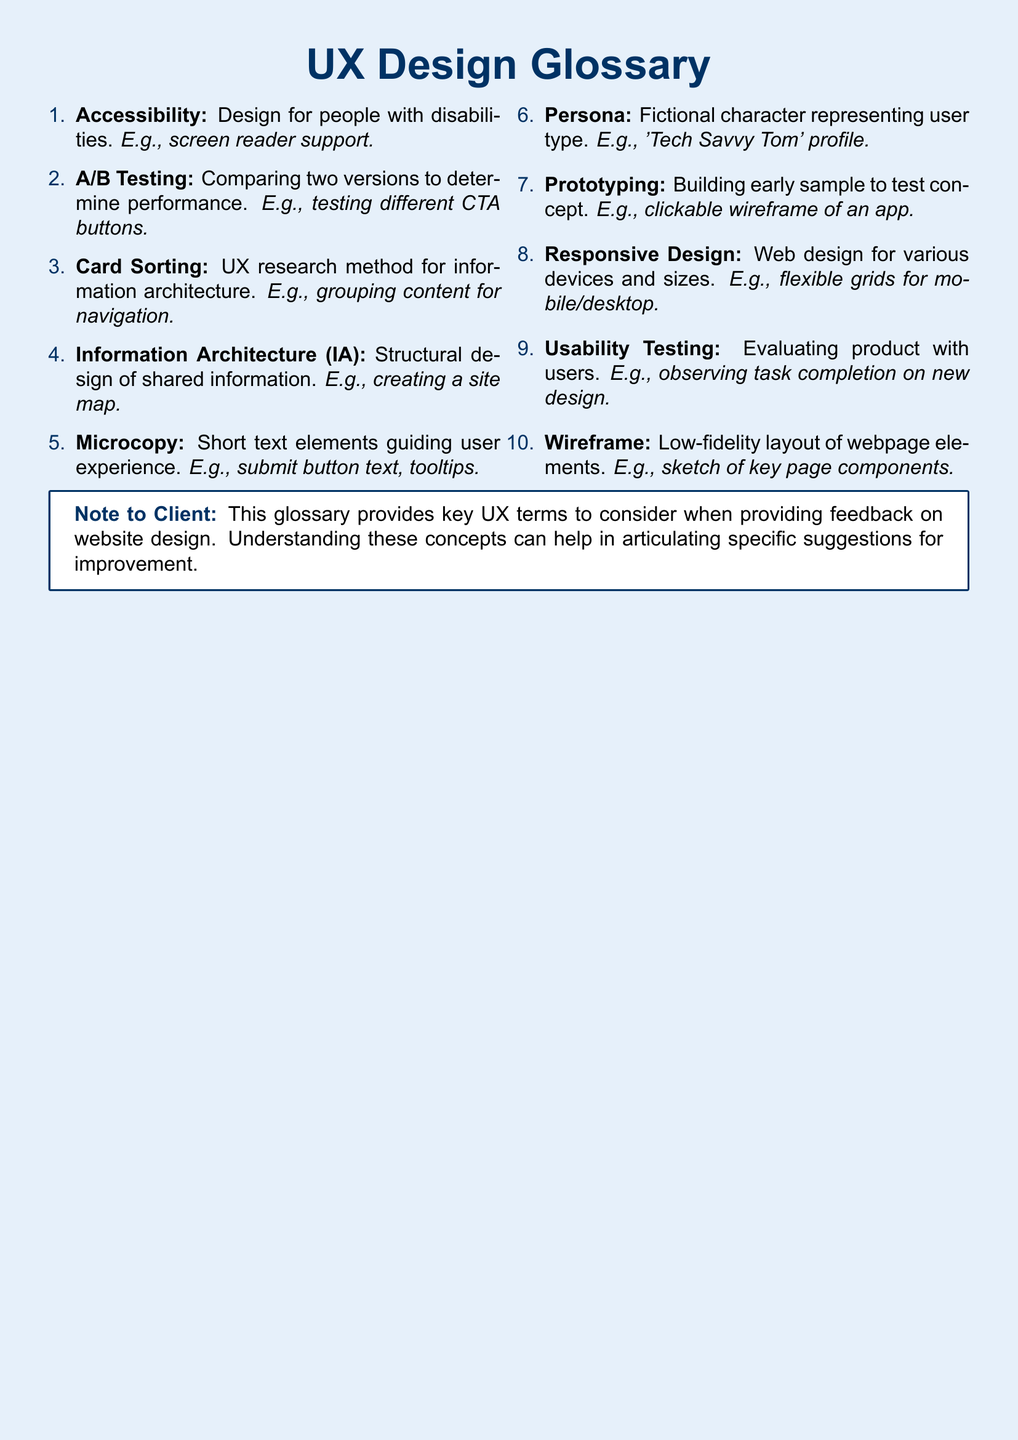What is the first term in the glossary? The first term listed in the glossary is "Accessibility."
Answer: Accessibility How many terms are defined in the glossary? There are ten terms defined in the glossary.
Answer: 10 What does "A/B Testing" compare? "A/B Testing" compares two versions to determine performance.
Answer: Two versions What example is given for "Microcopy"? The example provided for "Microcopy" is "submit button text, tooltips."
Answer: submit button text, tooltips What research method is used for information architecture? The research method used for information architecture is "Card Sorting."
Answer: Card Sorting Which term refers to a fictional character representing user type? The term referring to a fictional character is "Persona."
Answer: Persona What is the purpose of "Prototyping"? The purpose of "Prototyping" is to build an early sample to test a concept.
Answer: Build an early sample What design principle is described as "Web design for various devices and sizes"? The design principle described is "Responsive Design."
Answer: Responsive Design What type of layout does a "Wireframe" provide? A "Wireframe" provides a low-fidelity layout of webpage elements.
Answer: Low-fidelity layout 